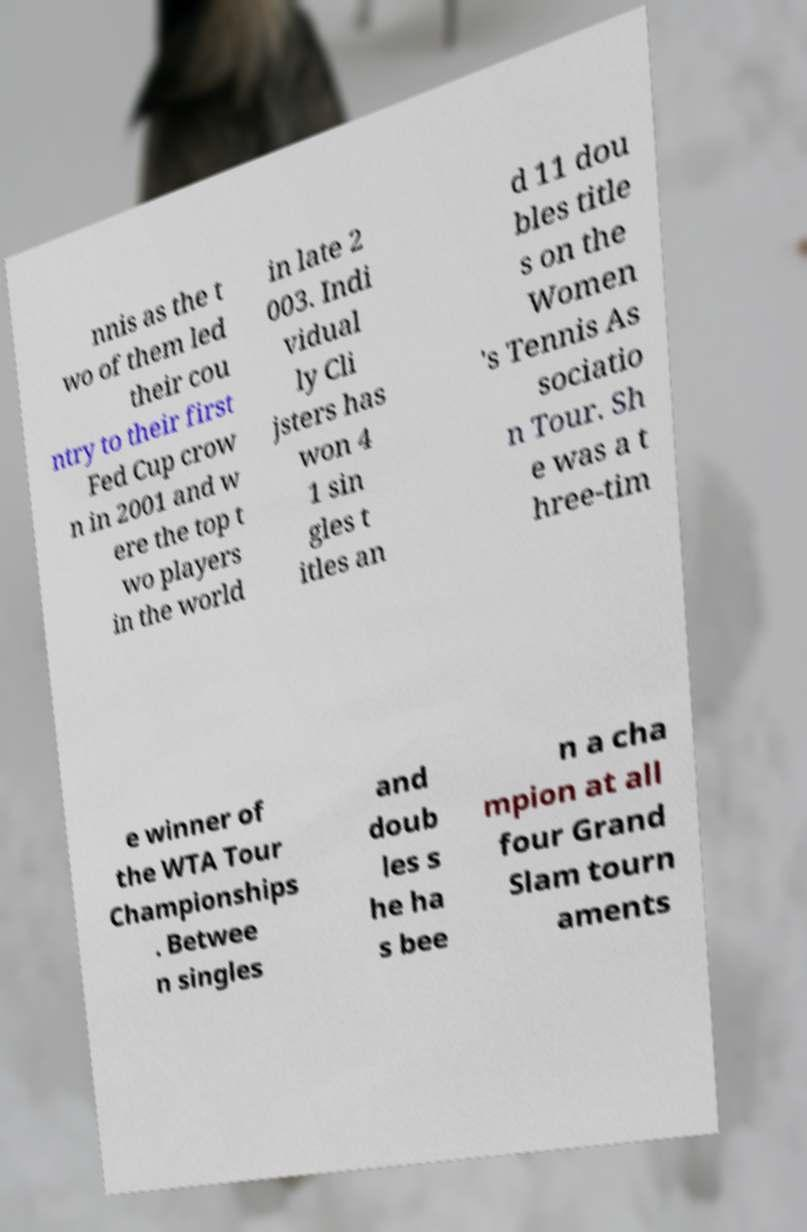Could you assist in decoding the text presented in this image and type it out clearly? nnis as the t wo of them led their cou ntry to their first Fed Cup crow n in 2001 and w ere the top t wo players in the world in late 2 003. Indi vidual ly Cli jsters has won 4 1 sin gles t itles an d 11 dou bles title s on the Women 's Tennis As sociatio n Tour. Sh e was a t hree-tim e winner of the WTA Tour Championships . Betwee n singles and doub les s he ha s bee n a cha mpion at all four Grand Slam tourn aments 